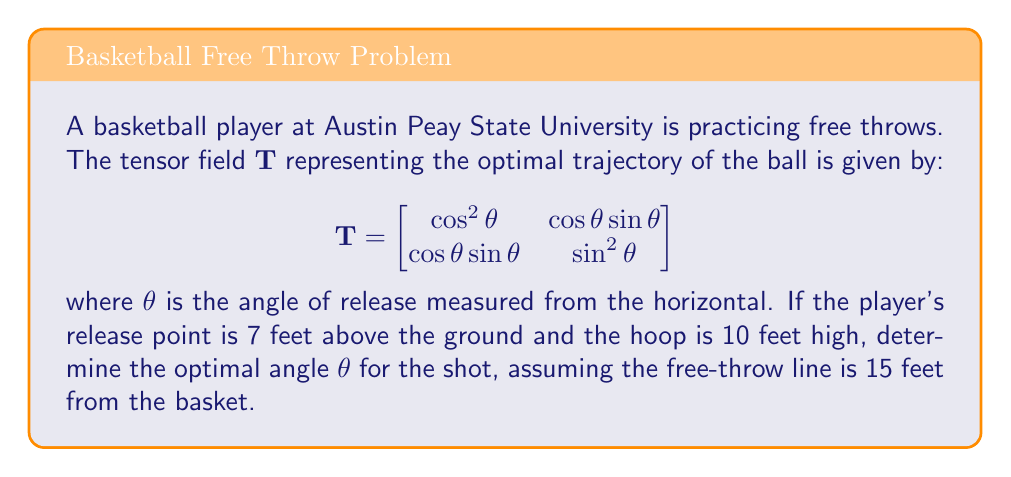Could you help me with this problem? Let's approach this step-by-step:

1) First, we need to understand what the tensor field represents. In this case, it describes the optimal trajectory of the ball. The eigenvalues of this tensor will give us information about the principal directions of the trajectory.

2) To find the eigenvalues, we solve the characteristic equation:

   $$\det(\mathbf{T} - \lambda\mathbf{I}) = 0$$

   $$\begin{vmatrix}
   \cos^2\theta - \lambda & \cos\theta\sin\theta \\
   \cos\theta\sin\theta & \sin^2\theta - \lambda
   \end{vmatrix} = 0$$

3) Expanding this:

   $$(\cos^2\theta - \lambda)(\sin^2\theta - \lambda) - (\cos\theta\sin\theta)^2 = 0$$
   $$\cos^2\theta\sin^2\theta - \lambda\cos^2\theta - \lambda\sin^2\theta + \lambda^2 - \cos^2\theta\sin^2\theta = 0$$
   $$\lambda^2 - \lambda(\cos^2\theta + \sin^2\theta) = 0$$
   $$\lambda^2 - \lambda = 0$$

4) Solving this, we get $\lambda = 0$ or $\lambda = 1$. The eigenvector corresponding to $\lambda = 1$ gives us the direction of the optimal trajectory.

5) Now, let's consider the geometry of the problem. We can set up a right triangle where:
   - The base is the horizontal distance to the hoop (15 feet)
   - The height is the difference in height between the hoop and the release point (10 - 7 = 3 feet)

6) The optimal angle $\theta$ is the angle this trajectory makes with the horizontal. We can find this using trigonometry:

   $$\tan\theta = \frac{\text{opposite}}{\text{adjacent}} = \frac{3}{15} = \frac{1}{5}$$

7) Therefore, the optimal angle is:

   $$\theta = \arctan(\frac{1}{5})$$

[asy]
import geometry;

size(200);
draw((0,0)--(15,0)--(15,3)--(0,0),black);
draw((0,0)--(15,3),red);
label("15 ft", (7.5,0), S);
label("3 ft", (15,1.5), E);
label("$\theta$", (1,0.5), NW);
[/asy]
Answer: $\theta = \arctan(\frac{1}{5}) \approx 11.31°$ 